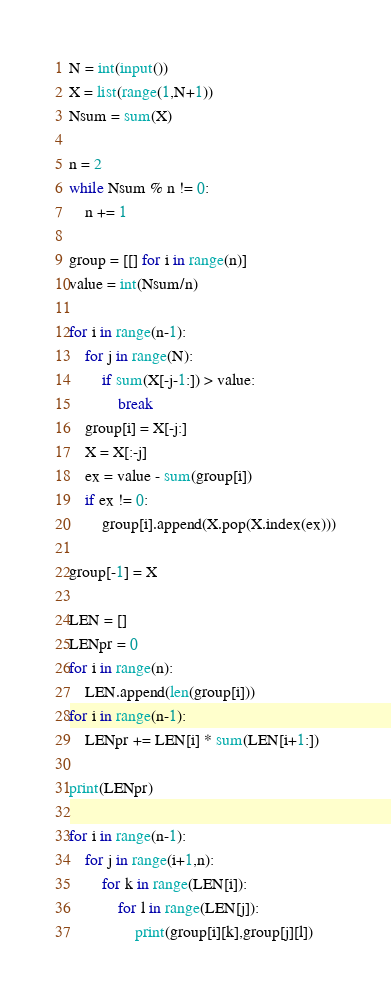<code> <loc_0><loc_0><loc_500><loc_500><_Python_>N = int(input())
X = list(range(1,N+1))
Nsum = sum(X)

n = 2 
while Nsum % n != 0:
    n += 1

group = [[] for i in range(n)]
value = int(Nsum/n)

for i in range(n-1):
    for j in range(N):
        if sum(X[-j-1:]) > value:
            break
    group[i] = X[-j:]
    X = X[:-j]
    ex = value - sum(group[i])
    if ex != 0:
        group[i].append(X.pop(X.index(ex)))

group[-1] = X

LEN = []
LENpr = 0
for i in range(n):
    LEN.append(len(group[i]))
for i in range(n-1):
    LENpr += LEN[i] * sum(LEN[i+1:])

print(LENpr)

for i in range(n-1):
    for j in range(i+1,n):
        for k in range(LEN[i]):
            for l in range(LEN[j]):
                print(group[i][k],group[j][l])

</code> 